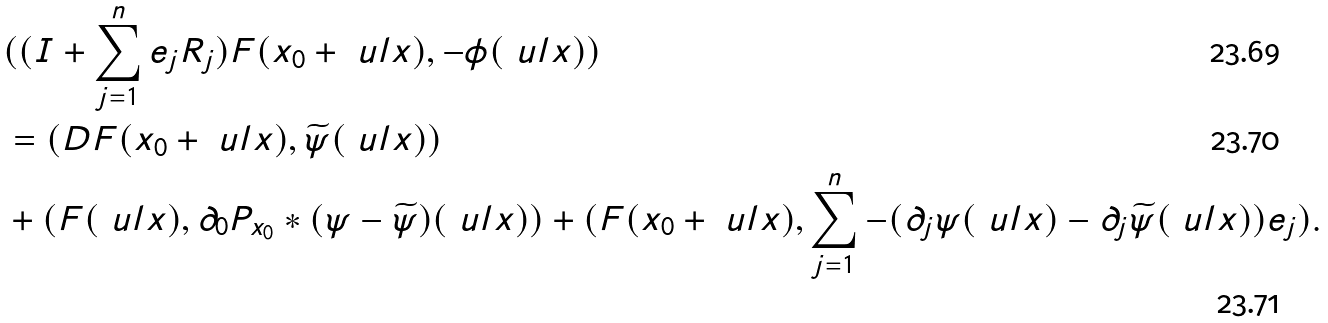<formula> <loc_0><loc_0><loc_500><loc_500>& ( ( I + \sum _ { j = 1 } ^ { n } e _ { j } R _ { j } ) F ( x _ { 0 } + \ u l x ) , - \phi ( \ u l x ) ) \\ & = ( D F ( x _ { 0 } + \ u l x ) , \widetilde { \psi } ( \ u l x ) ) \\ & + ( F ( \ u l x ) , \partial _ { 0 } P _ { x _ { 0 } } * ( \psi - \widetilde { \psi } ) ( \ u l x ) ) + ( F ( x _ { 0 } + \ u l x ) , \sum _ { j = 1 } ^ { n } - ( \partial _ { j } \psi ( \ u l x ) - \partial _ { j } \widetilde { \psi } ( \ u l x ) ) e _ { j } ) .</formula> 